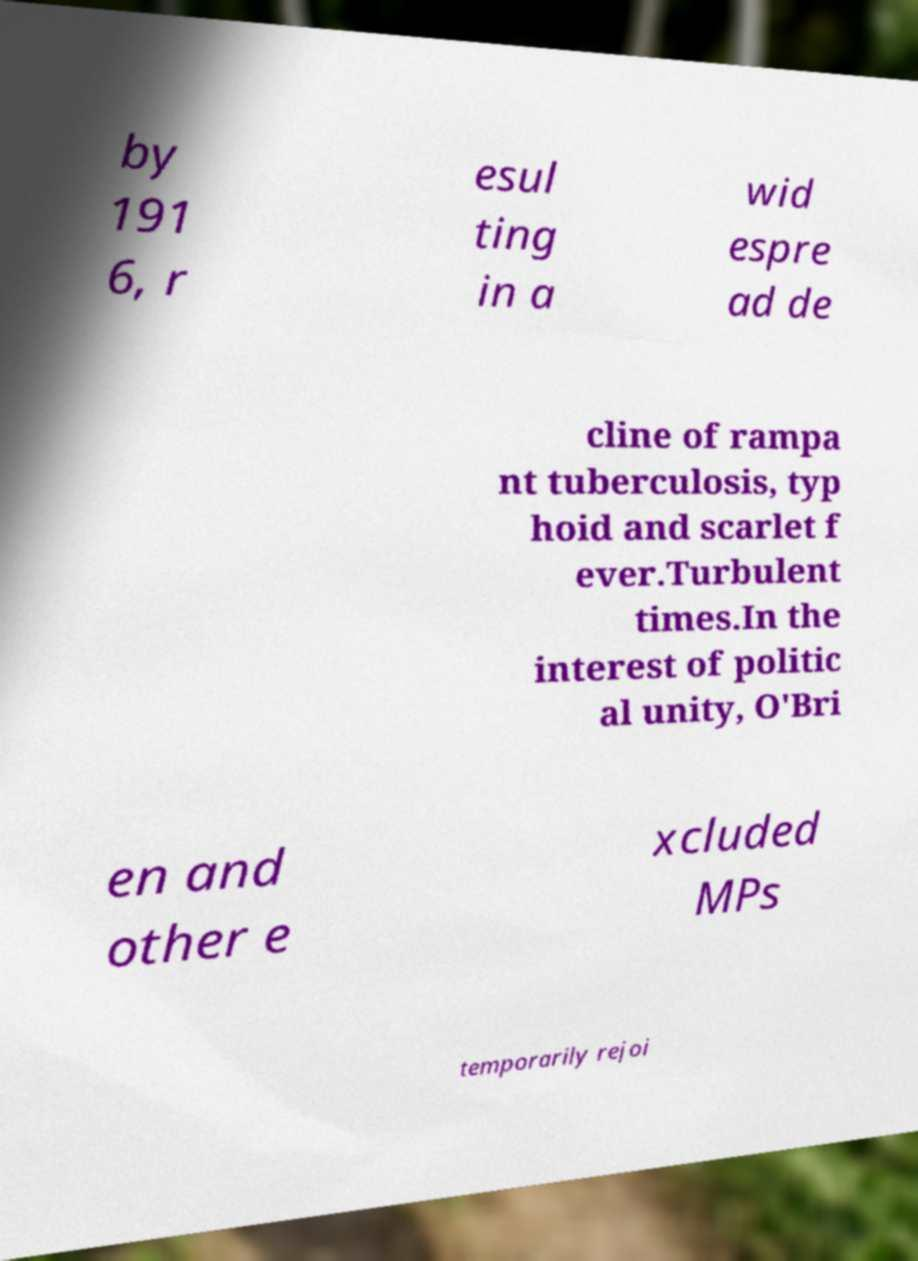For documentation purposes, I need the text within this image transcribed. Could you provide that? by 191 6, r esul ting in a wid espre ad de cline of rampa nt tuberculosis, typ hoid and scarlet f ever.Turbulent times.In the interest of politic al unity, O'Bri en and other e xcluded MPs temporarily rejoi 